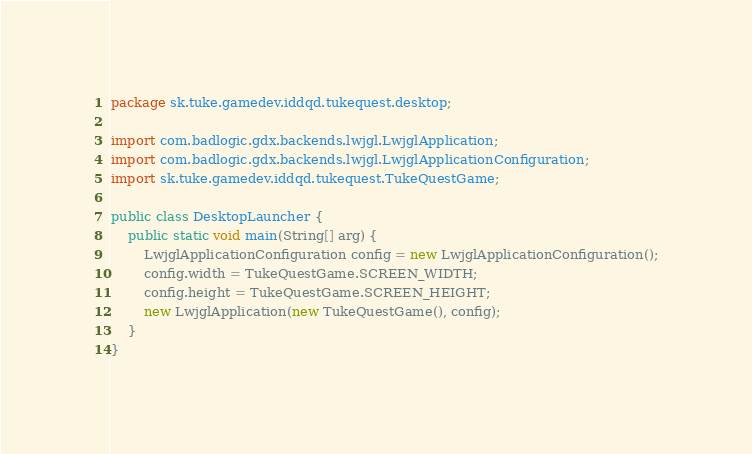<code> <loc_0><loc_0><loc_500><loc_500><_Java_>package sk.tuke.gamedev.iddqd.tukequest.desktop;

import com.badlogic.gdx.backends.lwjgl.LwjglApplication;
import com.badlogic.gdx.backends.lwjgl.LwjglApplicationConfiguration;
import sk.tuke.gamedev.iddqd.tukequest.TukeQuestGame;

public class DesktopLauncher {
    public static void main(String[] arg) {
        LwjglApplicationConfiguration config = new LwjglApplicationConfiguration();
        config.width = TukeQuestGame.SCREEN_WIDTH;
        config.height = TukeQuestGame.SCREEN_HEIGHT;
        new LwjglApplication(new TukeQuestGame(), config);
    }
}
</code> 